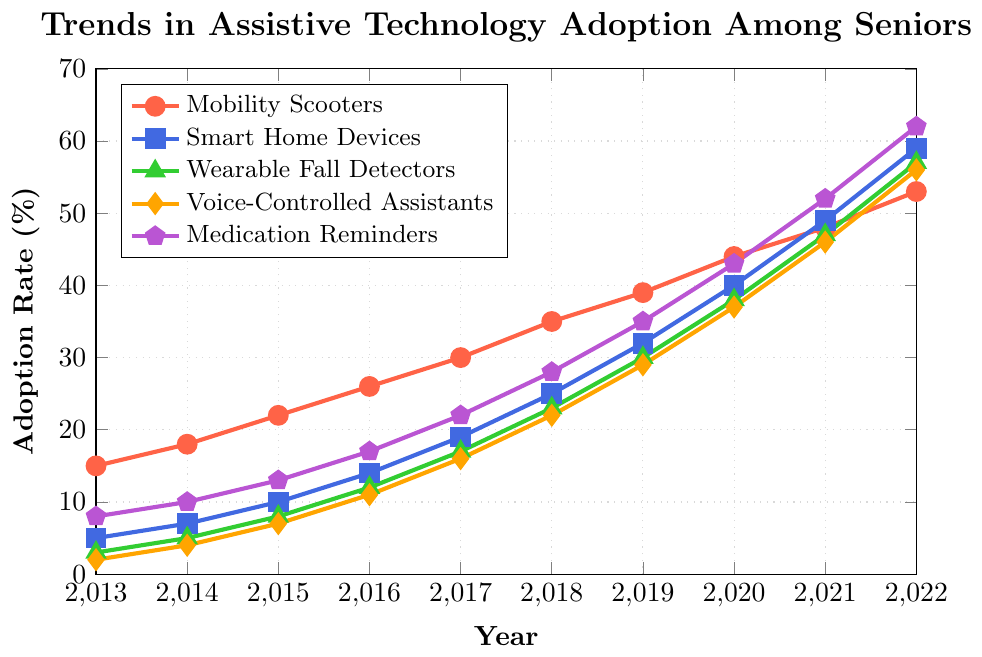Which assistive technology had the highest adoption rate in 2022? In 2022, Medication Reminders had the highest adoption rate of 62%, clearly higher than the other devices
Answer: Medication Reminders How much did the adoption rate of Smart Home Devices increase from 2013 to 2022? In 2013, the adoption rate for Smart Home Devices was 5%. In 2022, it was 59%. The increase is 59% - 5% = 54%
Answer: 54% Compare the adoption rates of Mobility Scooters and Wearable Fall Detectors in 2017. Which was higher and by how much? In 2017, Mobility Scooters had an adoption rate of 30%, and Wearable Fall Detectors had an adoption rate of 17%. The difference is 30% - 17% = 13%, with Mobility Scooters being higher
Answer: Mobility Scooters by 13% What was the adoption rate for Voice-Controlled Assistants in 2015, and how does it compare to the adoption rate of Medication Reminders in the same year? In 2015, the adoption rate of Voice-Controlled Assistants was 7%, and for Medication Reminders, it was 13%. The comparison shows that Medication Reminders had a 6% higher adoption rate
Answer: Medication Reminders by 6% Which device type had the smallest increase in adoption rate from 2018 to 2019? The adoption rates in 2018 and 2019 are compared for each device. The differences are:
Mobility Scooters: 39% - 35% = 4%
Smart Home Devices: 32% - 25% = 7%
Wearable Fall Detectors: 30% - 23% = 7%
Voice-Controlled Assistants: 29% - 22% = 7%
Medication Reminders: 35% - 28% = 7%
Mobility Scooters had the smallest increase of 4%
Answer: Mobility Scooters Calculate the average adoption rate of Voice-Controlled Assistants from 2013 to 2022. Sum the adoption rates of Voice-Controlled Assistants from 2013 to 2022: 2 + 4 + 7 + 11 + 16 + 22 + 29 + 37 + 46 + 56 = 230. Divide by the number of years (10): 230 / 10 = 23%
Answer: 23% Between 2016 and 2017, which device had the largest percentage increase in its adoption rate? Calculate the percentage increase for each device from 2016 to 2017:
Mobility Scooters: (30-26)/26 * 100 ≈ 15.38%
Smart Home Devices: (19-14)/14 * 100 ≈ 35.71%
Wearable Fall Detectors: (17-12)/12 * 100 ≈ 41.67%
Voice-Controlled Assistants: (16-11)/11 * 100 ≈ 45.45%
Medication Reminders: (22-17)/17 * 100 ≈ 29.41%
Voice-Controlled Assistants had the largest percentage increase
Answer: Voice-Controlled Assistants What is the median adoption rate of Wearable Fall Detectors over the observed years? The data for Wearable Fall Detectors are: 3, 5, 8, 12, 17, 23, 30, 38, 47, 57. To find the median, arrange the data in ascending order, then find the middle value(s). Here, (17 + 23)/2 = 20%
Answer: 20% 